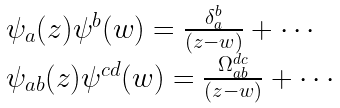<formula> <loc_0><loc_0><loc_500><loc_500>\begin{array} { l } { { \psi _ { a } ( z ) \psi ^ { b } ( w ) = \frac { \delta _ { a } ^ { b } } { ( z - w ) } + \cdots } } \\ { { \psi _ { a b } ( z ) \psi ^ { c d } ( w ) = \frac { \Omega _ { a b } ^ { d c } } { ( z - w ) } + \cdots } } \end{array}</formula> 